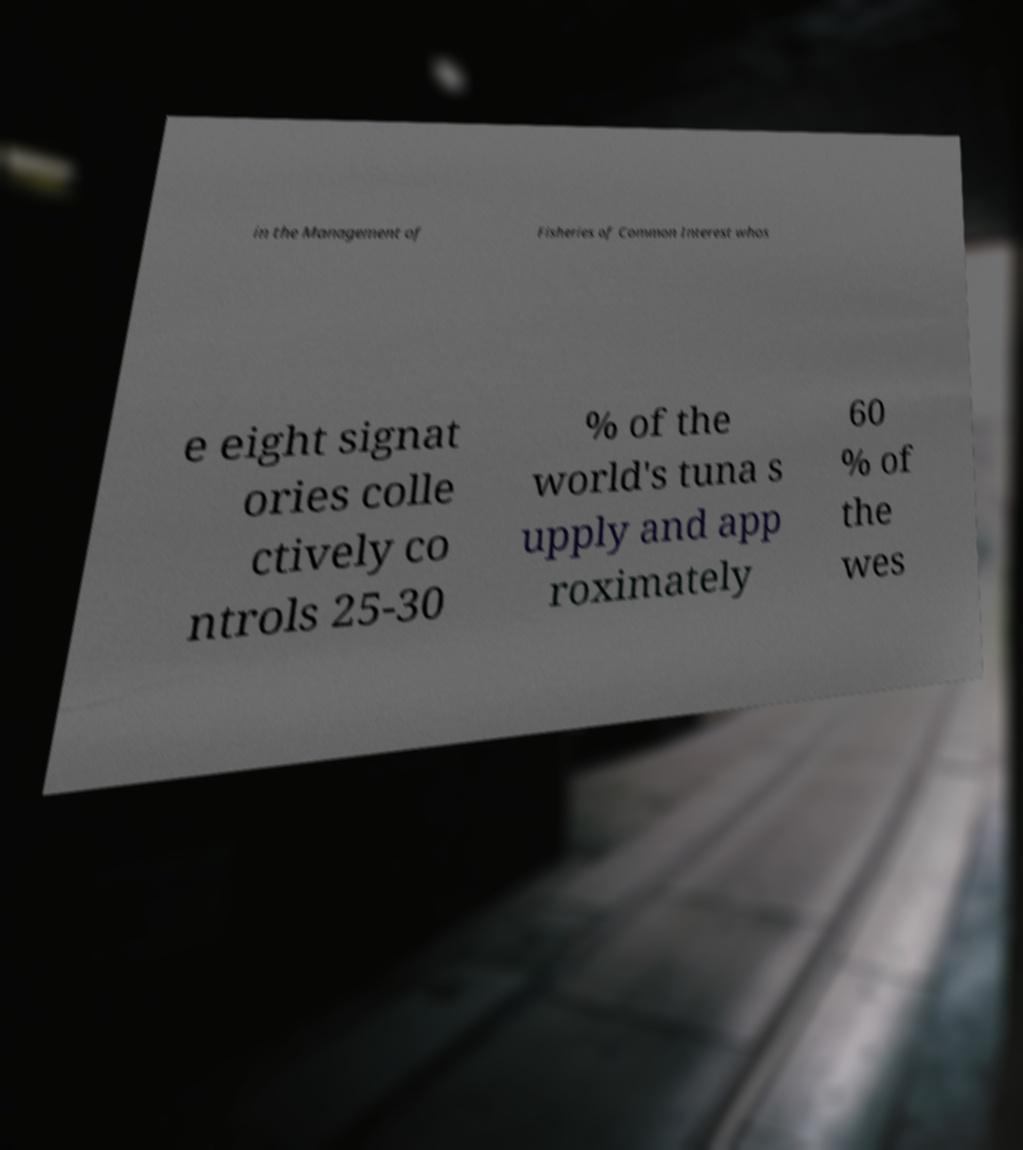I need the written content from this picture converted into text. Can you do that? in the Management of Fisheries of Common Interest whos e eight signat ories colle ctively co ntrols 25-30 % of the world's tuna s upply and app roximately 60 % of the wes 